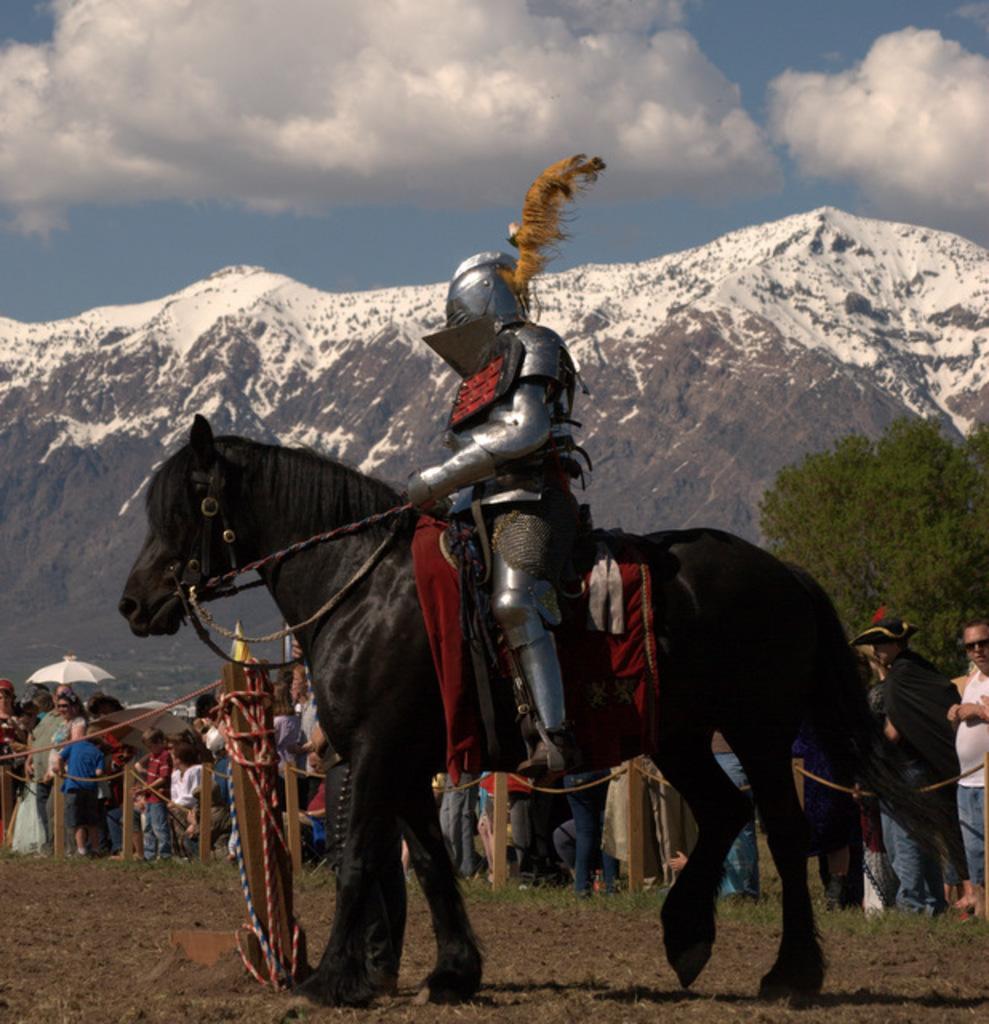In one or two sentences, can you explain what this image depicts? In this image I can see in the middle there is the black color horse. On this a person is sitting, this person wore war ornaments. At the back side a group of people are standing and observing this horse. On the right side there are trees and in the middle there are mountains with snow. At the top it is the cloudy sky. 